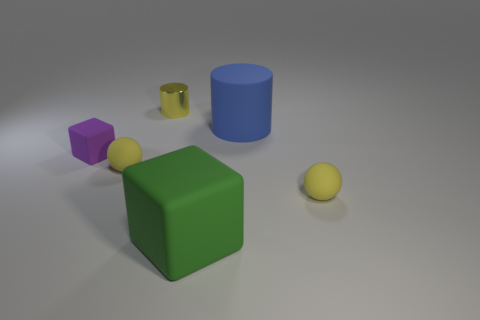What materials do the objects seem to be made from? The objects appear to be made from a smooth, matte plastic material. The large green cube and the smaller objects have a soft sheen, indicating a possible plastic or synthetic composition with a render-like quality, which suggests these might not be real-world objects but rather computer-generated models. 